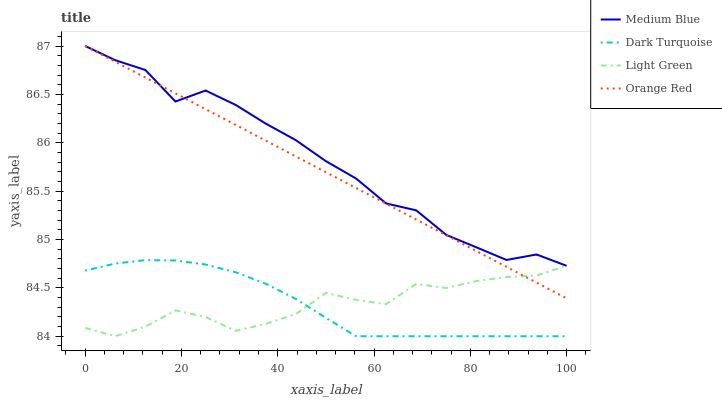Does Dark Turquoise have the minimum area under the curve?
Answer yes or no. Yes. Does Medium Blue have the maximum area under the curve?
Answer yes or no. Yes. Does Orange Red have the minimum area under the curve?
Answer yes or no. No. Does Orange Red have the maximum area under the curve?
Answer yes or no. No. Is Orange Red the smoothest?
Answer yes or no. Yes. Is Medium Blue the roughest?
Answer yes or no. Yes. Is Medium Blue the smoothest?
Answer yes or no. No. Is Orange Red the roughest?
Answer yes or no. No. Does Orange Red have the lowest value?
Answer yes or no. No. Does Orange Red have the highest value?
Answer yes or no. Yes. Does Light Green have the highest value?
Answer yes or no. No. Is Dark Turquoise less than Medium Blue?
Answer yes or no. Yes. Is Orange Red greater than Dark Turquoise?
Answer yes or no. Yes. Does Light Green intersect Dark Turquoise?
Answer yes or no. Yes. Is Light Green less than Dark Turquoise?
Answer yes or no. No. Is Light Green greater than Dark Turquoise?
Answer yes or no. No. Does Dark Turquoise intersect Medium Blue?
Answer yes or no. No. 